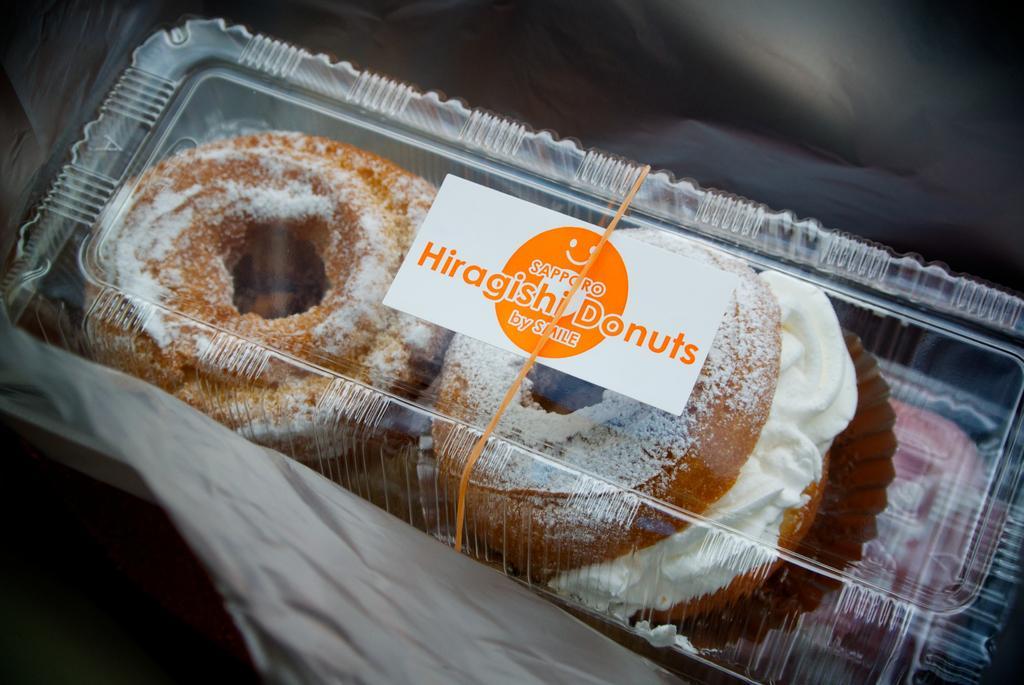Describe this image in one or two sentences. In this picture we can see a few donuts in the plastic boxes. We can see some text on a white card. A rubber band is visible on the plastic box. We can see a few objects at the bottom of the picture. 